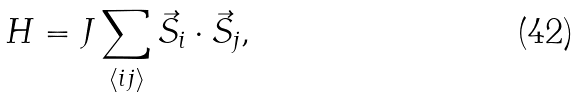Convert formula to latex. <formula><loc_0><loc_0><loc_500><loc_500>H = J \sum _ { \langle i j \rangle } \vec { S } _ { i } \cdot \vec { S } _ { j } ,</formula> 